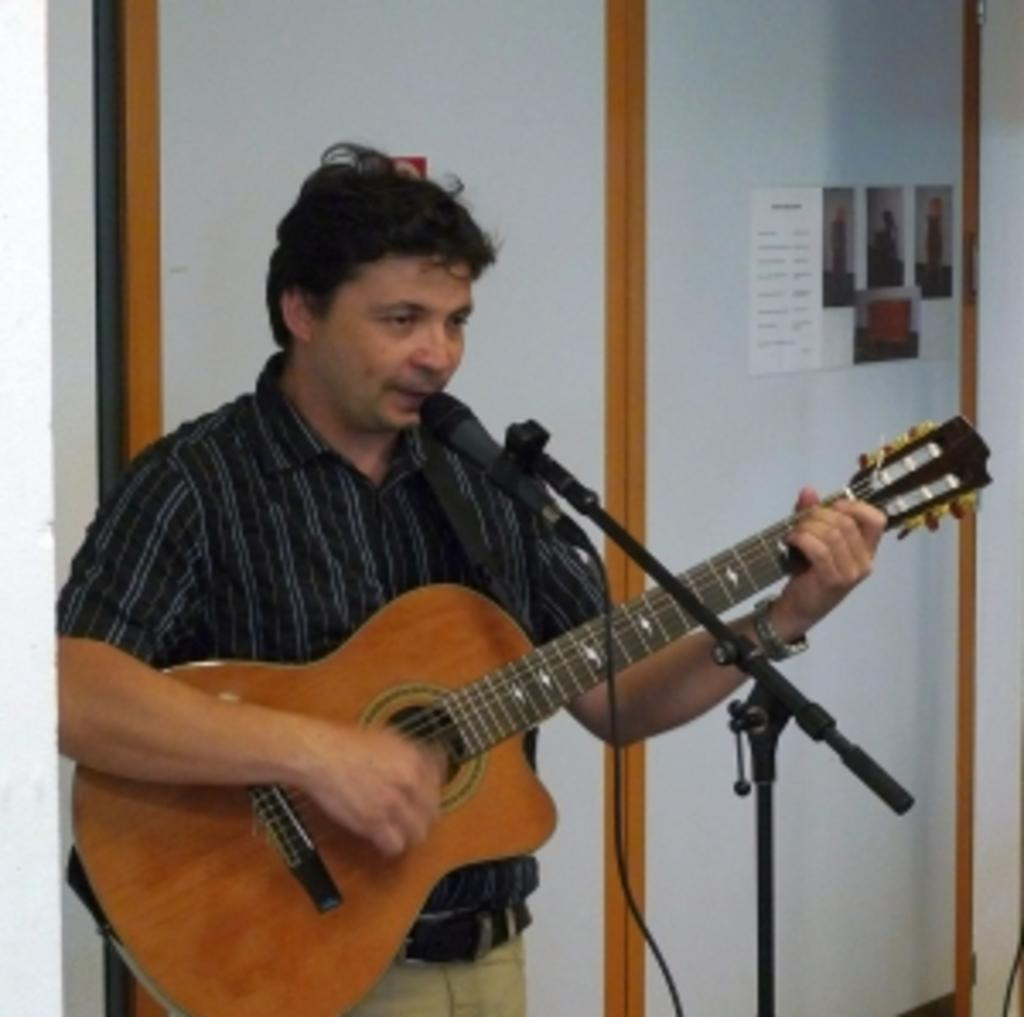What is the man in the image doing? The man is singing on a microphone and holding a guitar. What object is the man holding in the image? The man is holding a guitar. What can be seen in the background of the image? There is a wall in the background of the image. What is present on the wall in the image? There are notices and photos on the wall. Can you see any cobwebs on the wall in the image? There is no mention of cobwebs in the image, so we cannot determine if they are present or not. 